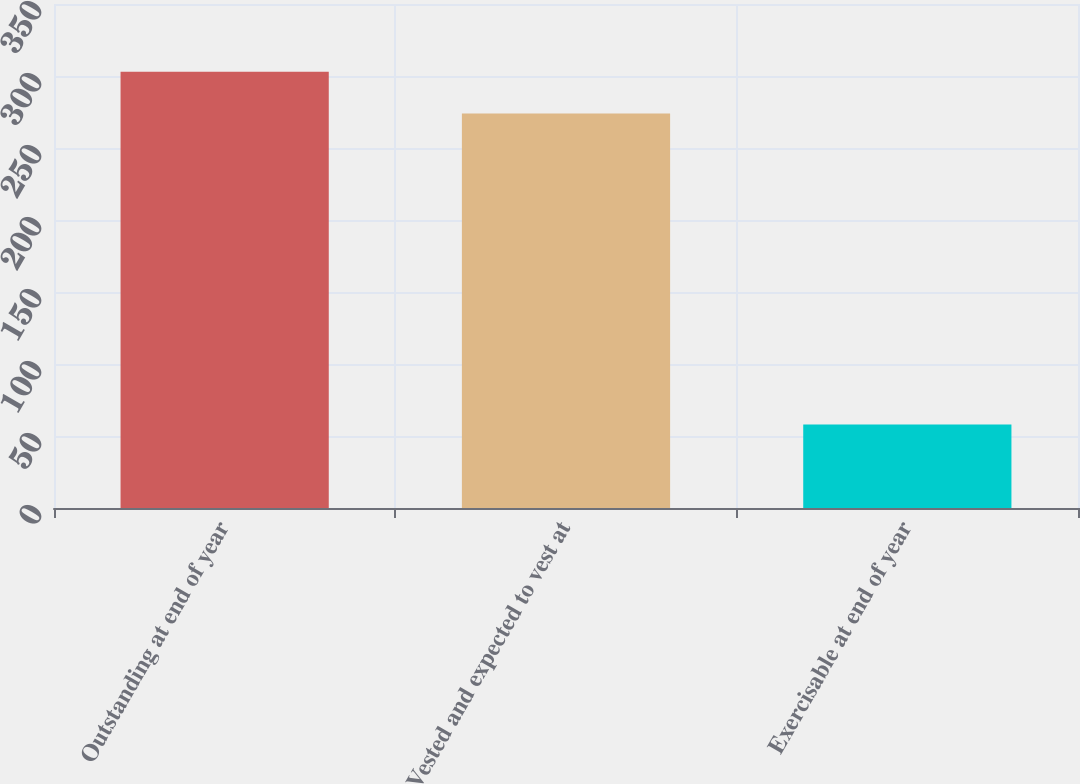Convert chart. <chart><loc_0><loc_0><loc_500><loc_500><bar_chart><fcel>Outstanding at end of year<fcel>Vested and expected to vest at<fcel>Exercisable at end of year<nl><fcel>303<fcel>274<fcel>58<nl></chart> 